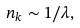<formula> <loc_0><loc_0><loc_500><loc_500>n _ { k } \sim 1 / \lambda ,</formula> 